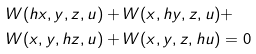Convert formula to latex. <formula><loc_0><loc_0><loc_500><loc_500>& W ( h x , y , z , u ) + W ( x , h y , z , u ) + \\ & W ( x , y , h z , u ) + W ( x , y , z , h u ) = 0</formula> 